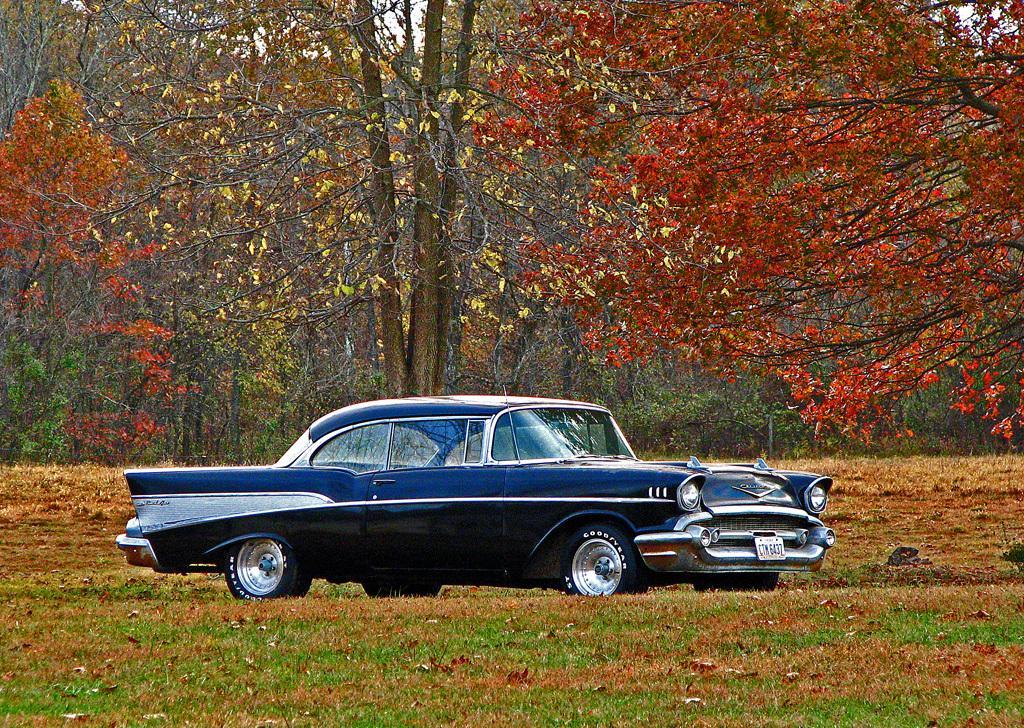Could you give a brief overview of what you see in this image? In this image I can see a blue color car. Back I can see few red,orange,brown and yellow color flowers and trees. 